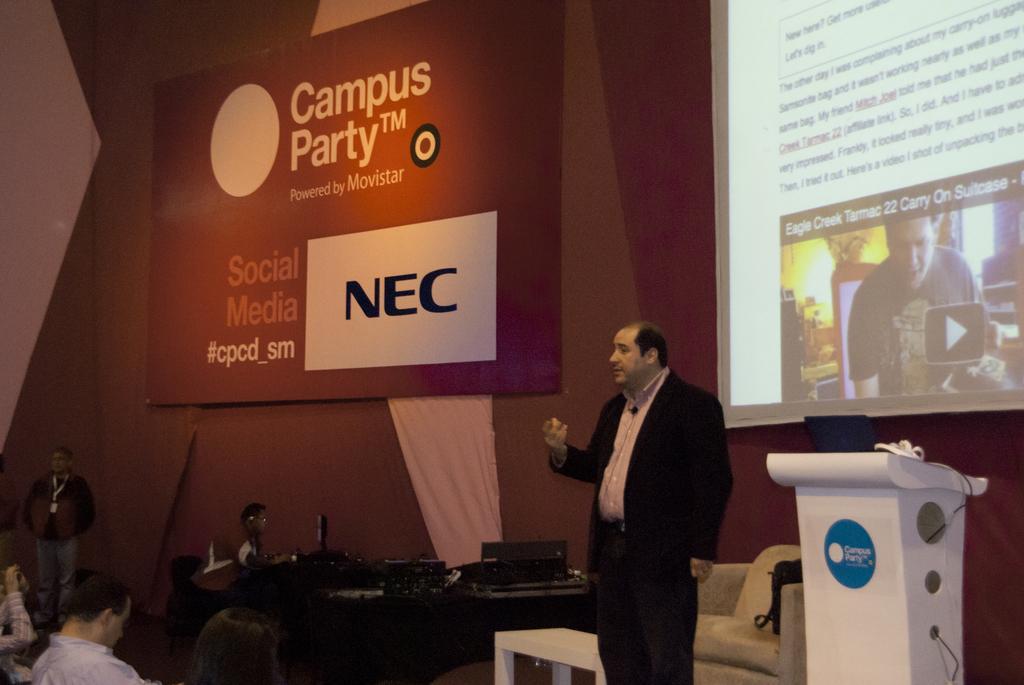Can you describe this image briefly? In this image there is a person standing on the stage and delivering a speech, behind the person there is a screen on the wall, beside the person there is a chair and the table with few equipment on the table, in front of the person there are a few audience seated on the chairs. 